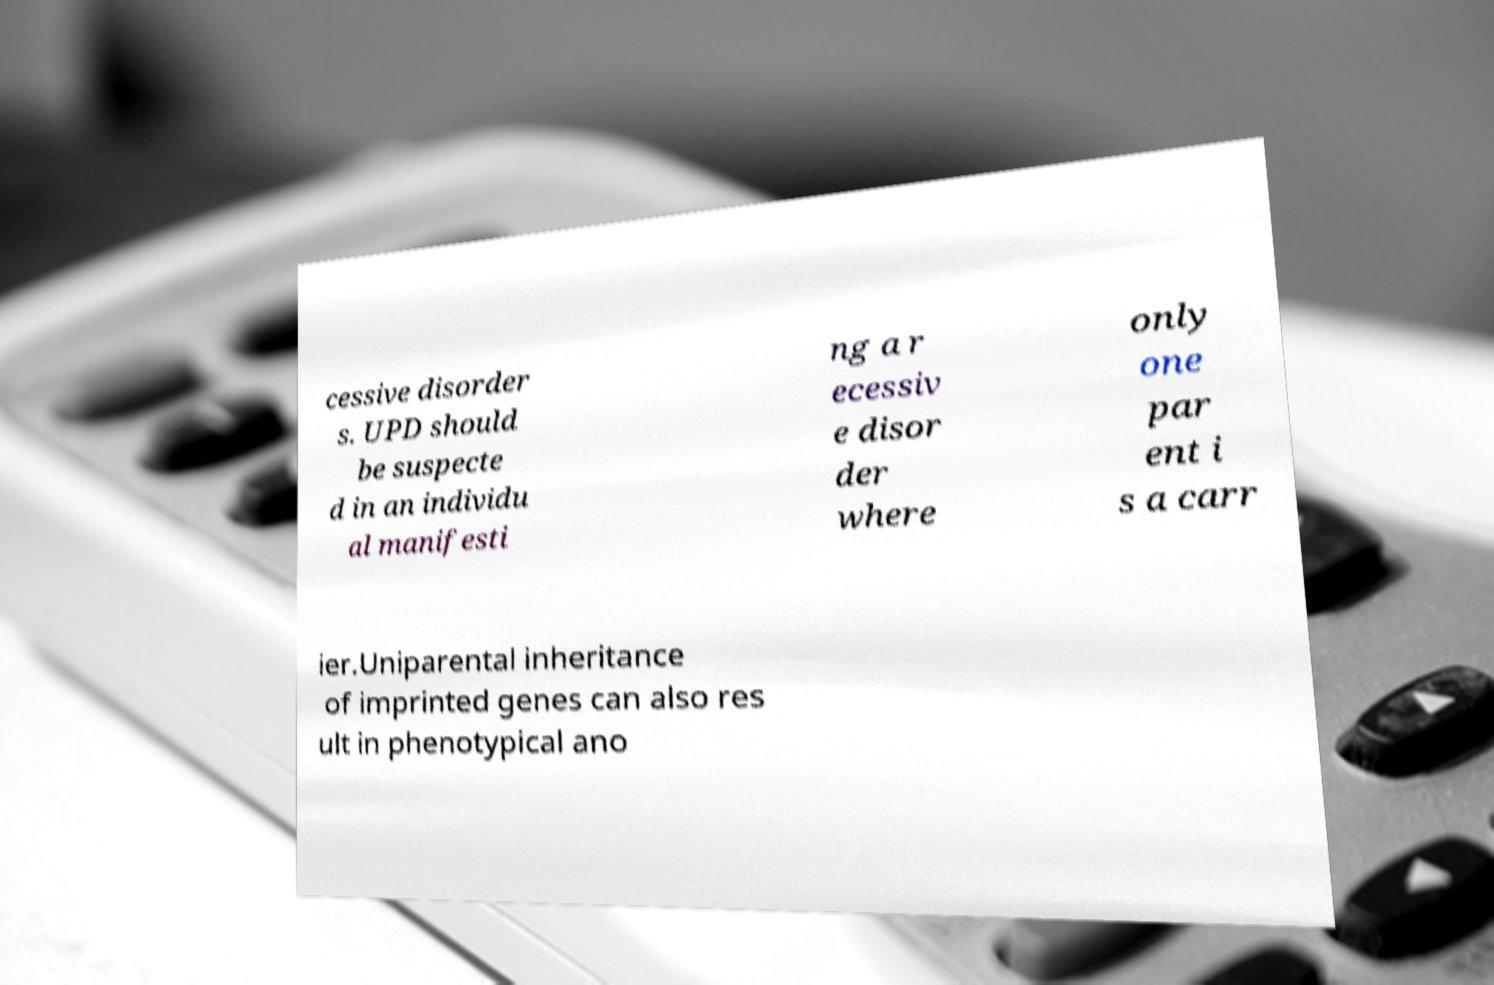I need the written content from this picture converted into text. Can you do that? cessive disorder s. UPD should be suspecte d in an individu al manifesti ng a r ecessiv e disor der where only one par ent i s a carr ier.Uniparental inheritance of imprinted genes can also res ult in phenotypical ano 